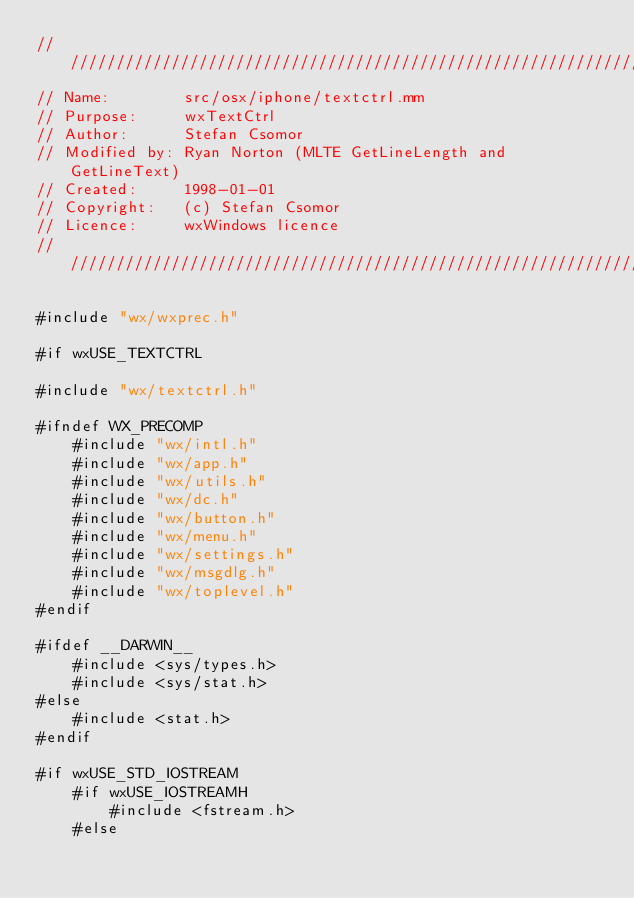<code> <loc_0><loc_0><loc_500><loc_500><_ObjectiveC_>/////////////////////////////////////////////////////////////////////////////
// Name:        src/osx/iphone/textctrl.mm
// Purpose:     wxTextCtrl
// Author:      Stefan Csomor
// Modified by: Ryan Norton (MLTE GetLineLength and GetLineText)
// Created:     1998-01-01
// Copyright:   (c) Stefan Csomor
// Licence:     wxWindows licence
/////////////////////////////////////////////////////////////////////////////

#include "wx/wxprec.h"

#if wxUSE_TEXTCTRL

#include "wx/textctrl.h"

#ifndef WX_PRECOMP
    #include "wx/intl.h"
    #include "wx/app.h"
    #include "wx/utils.h"
    #include "wx/dc.h"
    #include "wx/button.h"
    #include "wx/menu.h"
    #include "wx/settings.h"
    #include "wx/msgdlg.h"
    #include "wx/toplevel.h"
#endif

#ifdef __DARWIN__
    #include <sys/types.h>
    #include <sys/stat.h>
#else
    #include <stat.h>
#endif

#if wxUSE_STD_IOSTREAM
    #if wxUSE_IOSTREAMH
        #include <fstream.h>
    #else</code> 